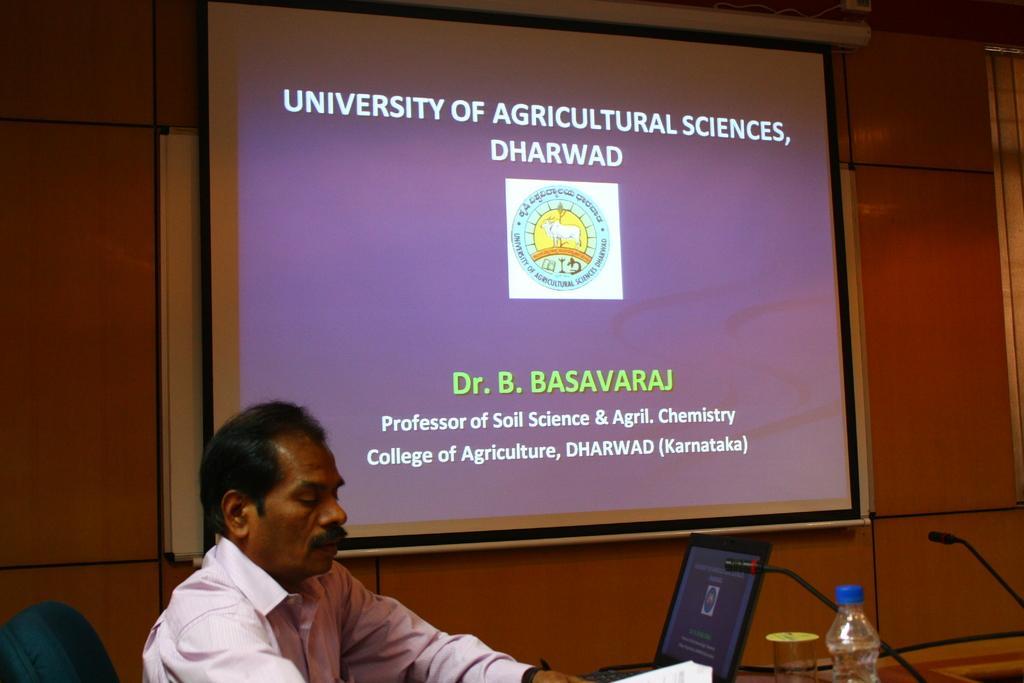<image>
Relay a brief, clear account of the picture shown. A screen with a power point for Dr. B. Basavaraj. 